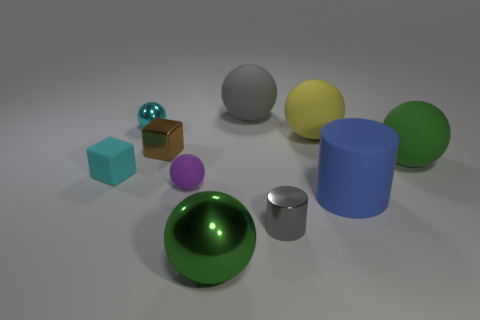Subtract all small rubber spheres. How many spheres are left? 5 Subtract 1 spheres. How many spheres are left? 5 Subtract all cyan balls. How many balls are left? 5 Subtract all green cylinders. How many green balls are left? 2 Subtract 1 purple balls. How many objects are left? 9 Subtract all cylinders. How many objects are left? 8 Subtract all purple spheres. Subtract all blue cubes. How many spheres are left? 5 Subtract all large yellow matte objects. Subtract all large green metallic objects. How many objects are left? 8 Add 9 green metallic objects. How many green metallic objects are left? 10 Add 9 small green objects. How many small green objects exist? 9 